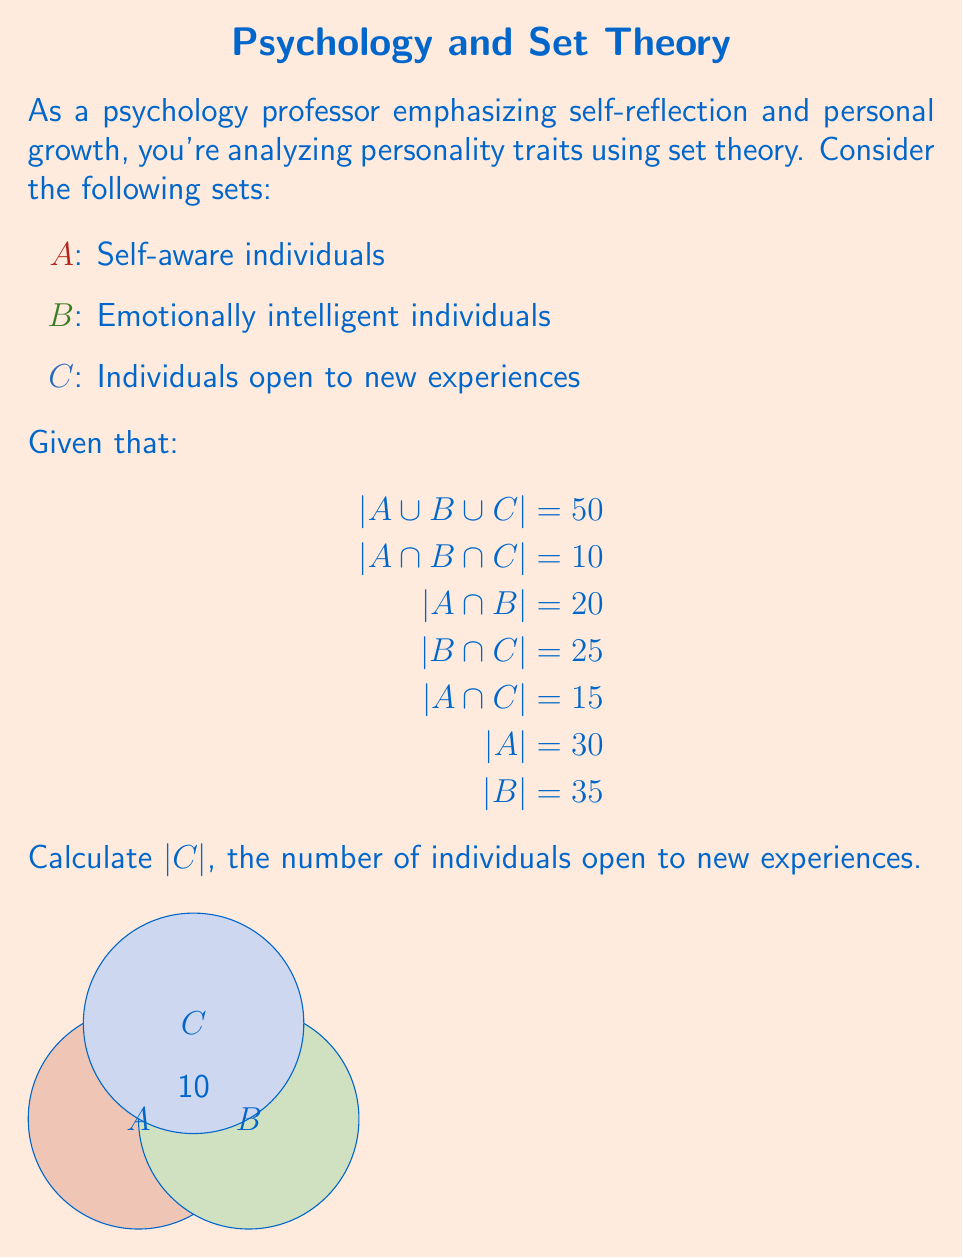Can you solve this math problem? Let's approach this step-by-step using the inclusion-exclusion principle:

1) The inclusion-exclusion principle for three sets is:
   $$|A \cup B \cup C| = |A| + |B| + |C| - |A \cap B| - |A \cap C| - |B \cap C| + |A \cap B \cap C|$$

2) We're given that $|A \cup B \cup C| = 50$, so let's substitute the known values:
   $$50 = 30 + 35 + |C| - 20 - 15 - 25 + 10$$

3) Simplify the right side of the equation:
   $$50 = 65 + |C| - 60 + 10$$
   $$50 = 15 + |C|$$

4) Solve for $|C|$:
   $$|C| = 50 - 15 = 35$$

Therefore, the number of individuals open to new experiences (set C) is 35.

This result aligns with the concept of self-reflection and personal growth, as openness to new experiences is a key factor in personal development. It's interesting to note that this number is equal to the number of emotionally intelligent individuals (set B), which could prompt further discussion on the relationship between these traits in the context of self-growth.
Answer: $|C| = 35$ 